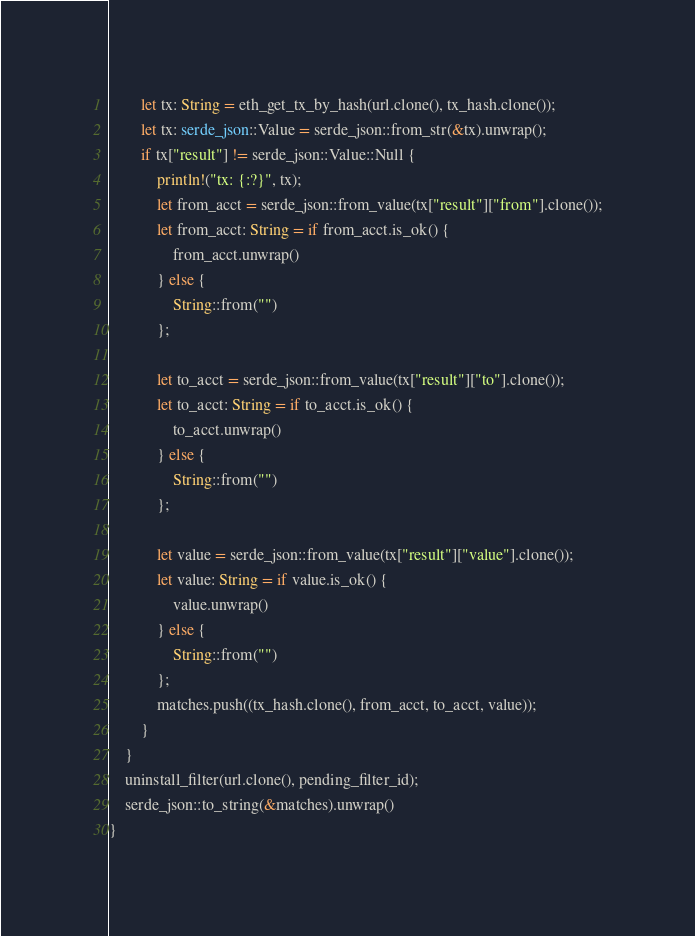<code> <loc_0><loc_0><loc_500><loc_500><_Rust_>        let tx: String = eth_get_tx_by_hash(url.clone(), tx_hash.clone());
        let tx: serde_json::Value = serde_json::from_str(&tx).unwrap();
        if tx["result"] != serde_json::Value::Null {
            println!("tx: {:?}", tx);
            let from_acct = serde_json::from_value(tx["result"]["from"].clone());
            let from_acct: String = if from_acct.is_ok() {
                from_acct.unwrap()
            } else {
                String::from("")
            };

            let to_acct = serde_json::from_value(tx["result"]["to"].clone());
            let to_acct: String = if to_acct.is_ok() {
                to_acct.unwrap()
            } else {
                String::from("")
            };

            let value = serde_json::from_value(tx["result"]["value"].clone());
            let value: String = if value.is_ok() {
                value.unwrap()
            } else {
                String::from("")
            };
            matches.push((tx_hash.clone(), from_acct, to_acct, value));
        }
    }
    uninstall_filter(url.clone(), pending_filter_id);
    serde_json::to_string(&matches).unwrap()
}
</code> 